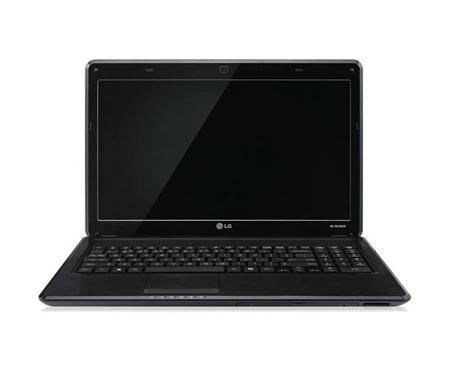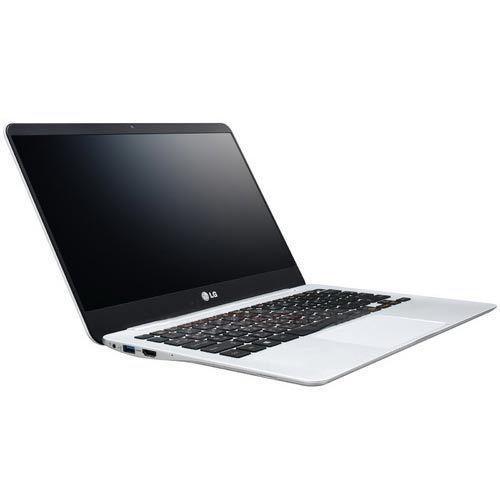The first image is the image on the left, the second image is the image on the right. For the images shown, is this caption "Each image contains exactly one open laptop, at least one image contains a laptop with something displayed on its screen, and the laptops on the left and right face different directions." true? Answer yes or no. No. The first image is the image on the left, the second image is the image on the right. Analyze the images presented: Is the assertion "At least one of the laptops has a blank screen." valid? Answer yes or no. Yes. 